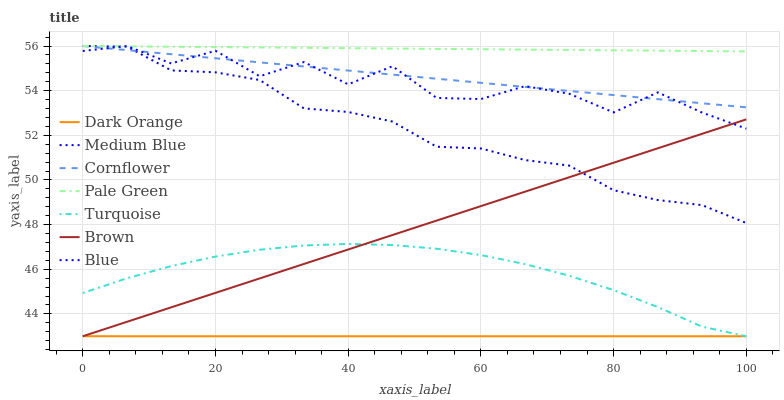Does Dark Orange have the minimum area under the curve?
Answer yes or no. Yes. Does Pale Green have the maximum area under the curve?
Answer yes or no. Yes. Does Turquoise have the minimum area under the curve?
Answer yes or no. No. Does Turquoise have the maximum area under the curve?
Answer yes or no. No. Is Brown the smoothest?
Answer yes or no. Yes. Is Blue the roughest?
Answer yes or no. Yes. Is Dark Orange the smoothest?
Answer yes or no. No. Is Dark Orange the roughest?
Answer yes or no. No. Does Medium Blue have the lowest value?
Answer yes or no. No. Does Cornflower have the highest value?
Answer yes or no. Yes. Does Turquoise have the highest value?
Answer yes or no. No. Is Dark Orange less than Blue?
Answer yes or no. Yes. Is Medium Blue greater than Turquoise?
Answer yes or no. Yes. Does Dark Orange intersect Blue?
Answer yes or no. No. 